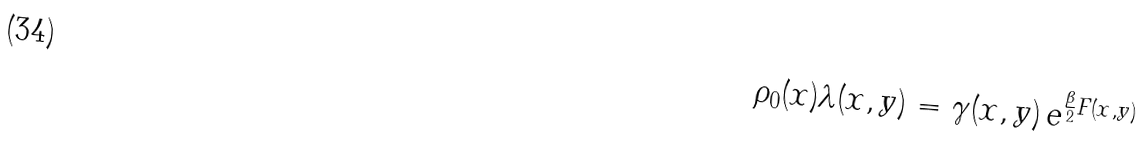Convert formula to latex. <formula><loc_0><loc_0><loc_500><loc_500>\rho _ { 0 } ( x ) \lambda ( x , y ) = \gamma ( x , y ) \, e ^ { \frac { \beta } { 2 } F ( x , y ) }</formula> 